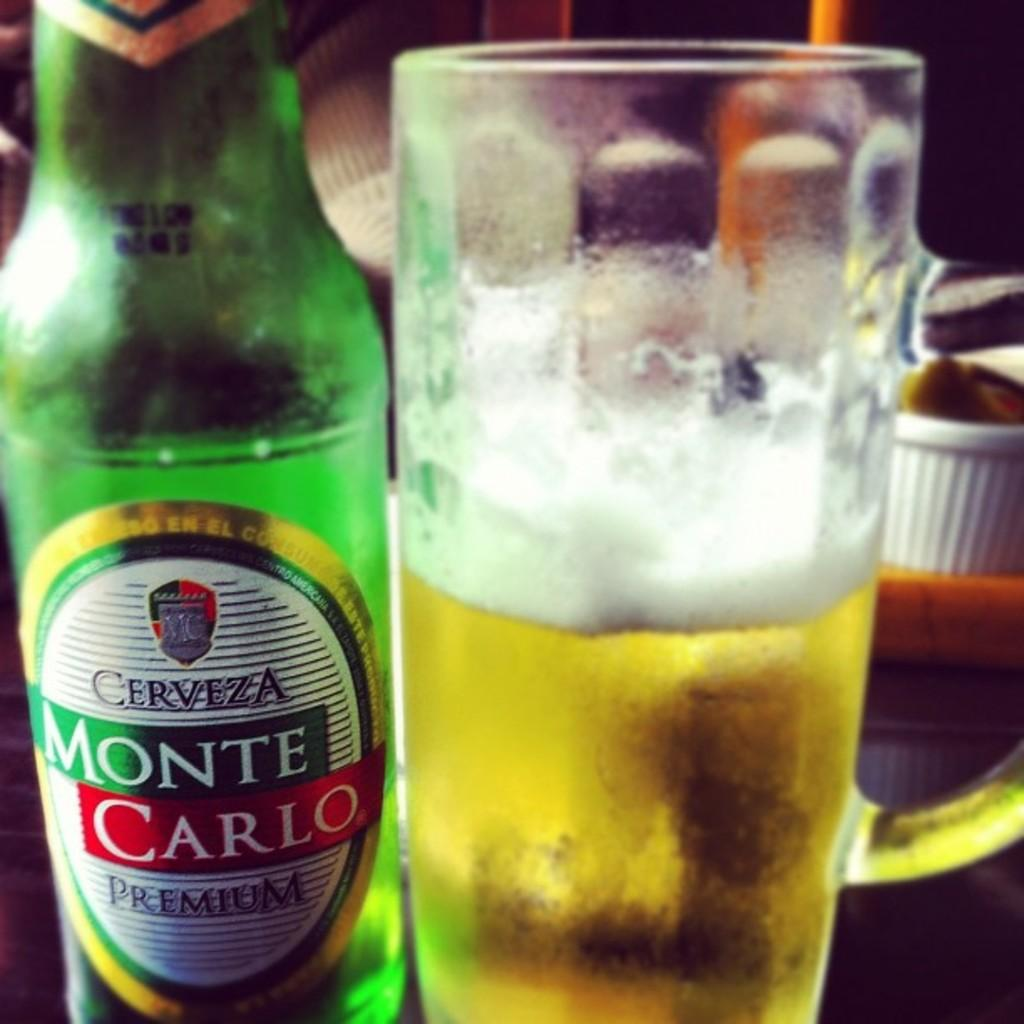<image>
Offer a succinct explanation of the picture presented. A botle of Cerveza Monte Carlo Premium beer next to a half full mug. 